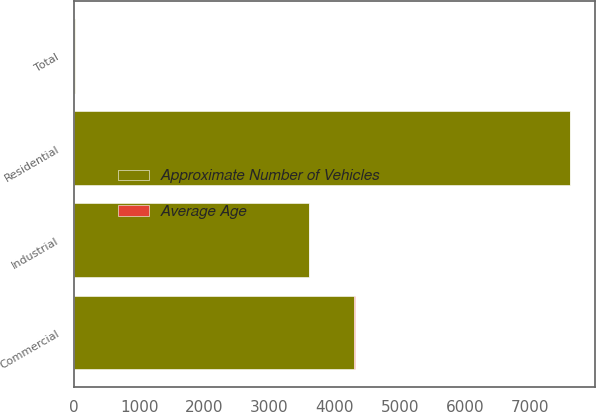<chart> <loc_0><loc_0><loc_500><loc_500><stacked_bar_chart><ecel><fcel>Residential<fcel>Commercial<fcel>Industrial<fcel>Total<nl><fcel>Approximate Number of Vehicles<fcel>7600<fcel>4300<fcel>3600<fcel>9<nl><fcel>Average Age<fcel>7<fcel>6<fcel>9<fcel>7<nl></chart> 